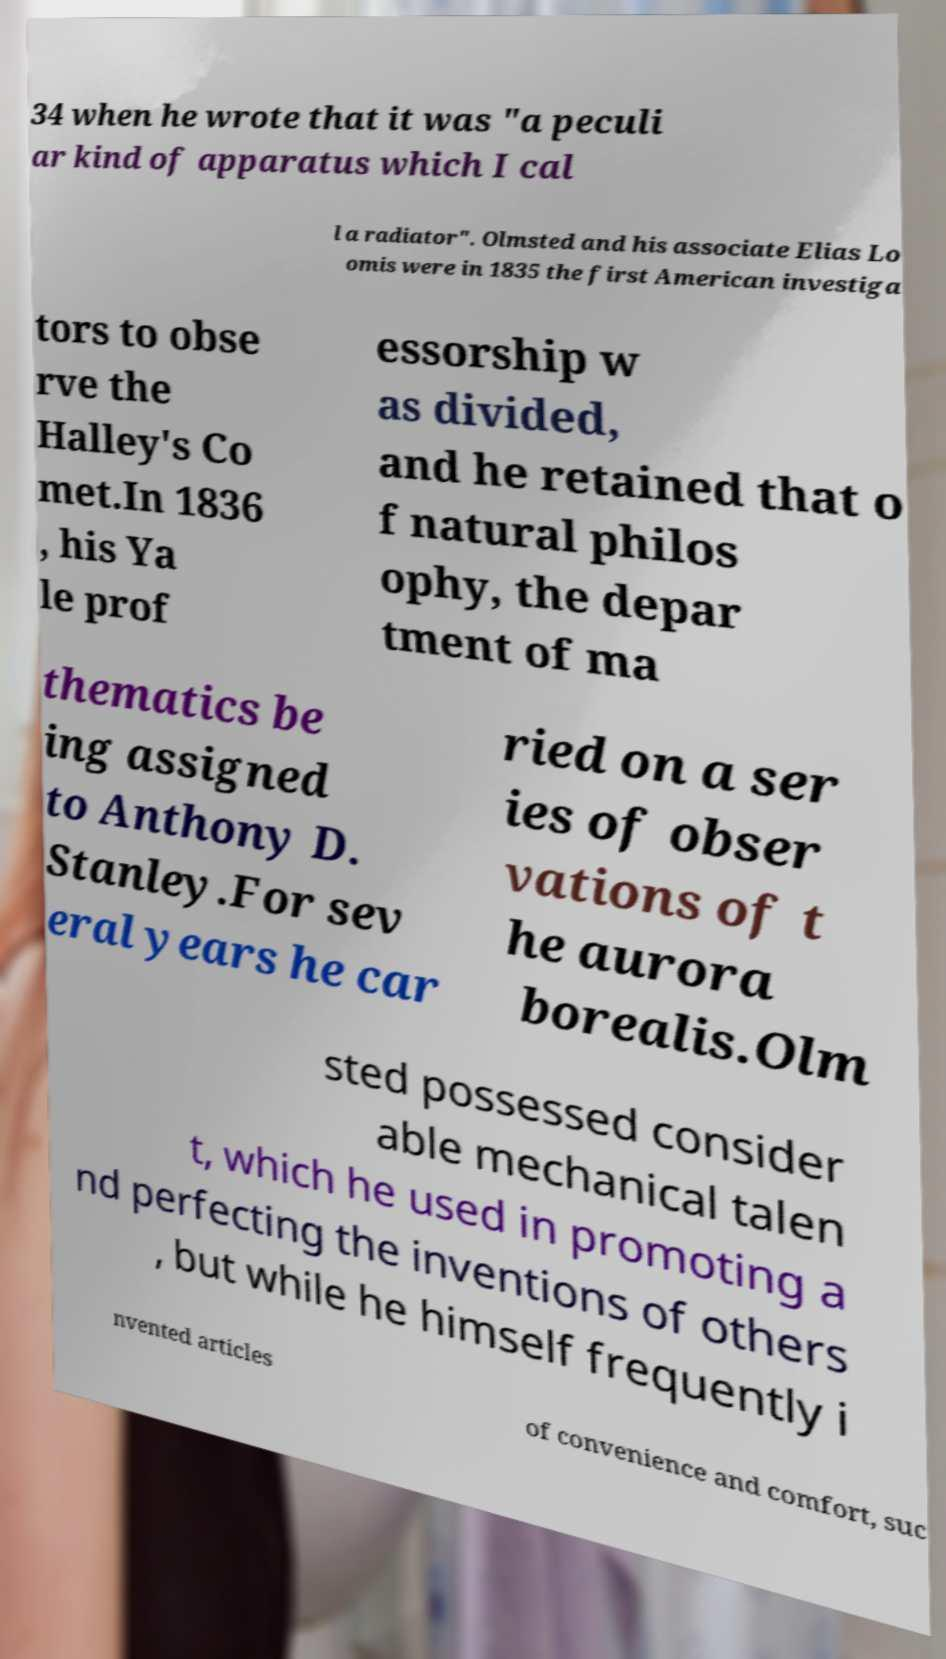There's text embedded in this image that I need extracted. Can you transcribe it verbatim? 34 when he wrote that it was "a peculi ar kind of apparatus which I cal l a radiator". Olmsted and his associate Elias Lo omis were in 1835 the first American investiga tors to obse rve the Halley's Co met.In 1836 , his Ya le prof essorship w as divided, and he retained that o f natural philos ophy, the depar tment of ma thematics be ing assigned to Anthony D. Stanley.For sev eral years he car ried on a ser ies of obser vations of t he aurora borealis.Olm sted possessed consider able mechanical talen t, which he used in promoting a nd perfecting the inventions of others , but while he himself frequently i nvented articles of convenience and comfort, suc 